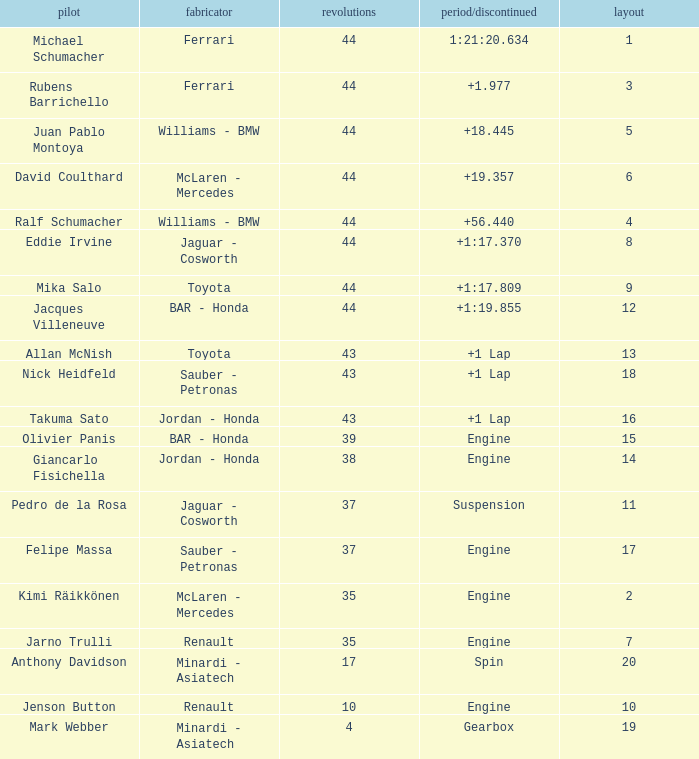What was the retired time on someone who had 43 laps on a grip of 18? +1 Lap. 